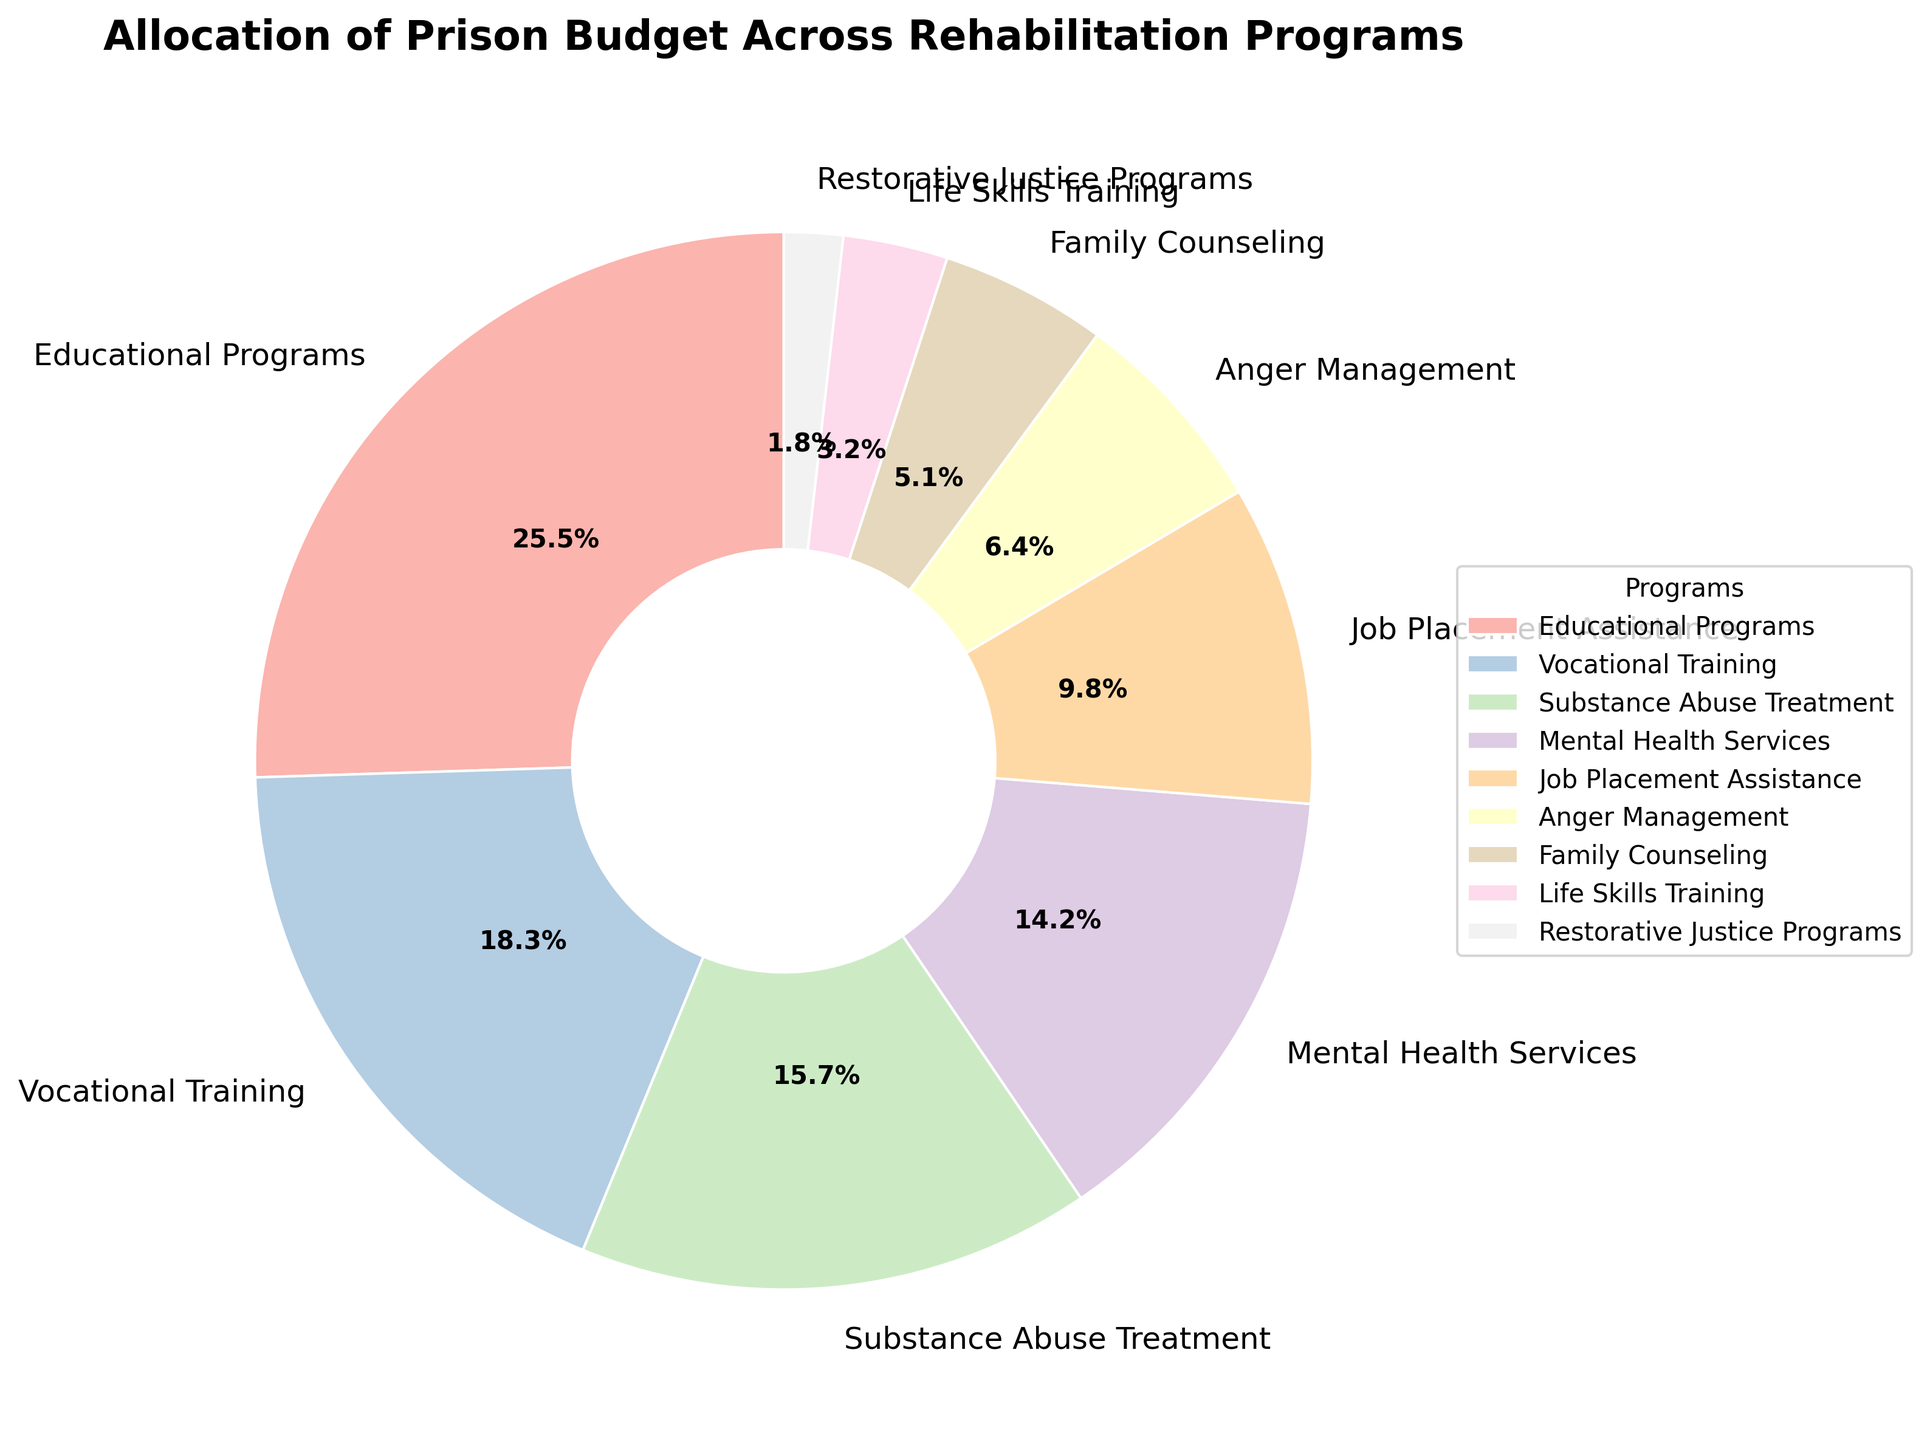What program receives the largest percentage of the budget? Look at the largest section of the pie chart and check the label. The largest section is labeled as "Educational Programs" with 25.5%.
Answer: Educational Programs Which program gets the least amount of budget? Identify the smallest section of the pie chart and check its label. The smallest section is "Restorative Justice Programs," which has 1.8%.
Answer: Restorative Justice Programs How much more budget is allocated to Educational Programs than to Vocational Training? Identify the percentages for both programs (25.5% for Educational Programs and 18.3% for Vocational Training). Subtract the smaller from the larger: 25.5 - 18.3.
Answer: 7.2% What's the total percentage of budget allocation for Substance Abuse Treatment and Mental Health Services combined? Identify the percentages for both programs (15.7% for Substance Abuse Treatment and 14.2% for Mental Health Services). Add them up: 15.7 + 14.2.
Answer: 29.9% Is the budget for Job Placement Assistance greater than that for Anger Management? Identify the percentages for both programs (9.8% for Job Placement Assistance and 6.4% for Anger Management). Compare the values: 9.8 > 6.4.
Answer: Yes Which program has roughly half the budget allocation of Educational Programs? Identify the percentage for Educational Programs (25.5%). Find a program with a percentage close to half of this (12.75%). The closest is Mental Health Services with 14.2%.
Answer: Mental Health Services Which program's budget allocation is closer to that of Family Counseling: Anger Management or Life Skills Training? Identify the percentages for all three programs (5.1% for Family Counseling, 6.4% for Anger Management, 3.2% for Life Skills Training). Calculate the differences: 6.4 - 5.1 = 1.3 and 5.1 - 3.2 = 1.9.
Answer: Anger Management Which programs combined make up approximately one-third of the budget? Identify the total budget (100%) and approximate one-third of it (33.3%). Check combinations: Educational Programs (25.5%) + Restorative Justice Programs (1.8%) + Job Placement Assistance (9.8%). 25.5 + 1.8 + 9.8 = 37.1, too high. Substance Abuse Treatment (15.7%) + Mental Health Services (14.2%) + Anger Management (6.4%). 15.7 + 14.2 + 6.4 = 36.3, still high. Substance Abuse Treatment (15.7%) + Vocational Training (18.3%) = 34%, close enough.
Answer: Substance Abuse Treatment and Vocational Training 